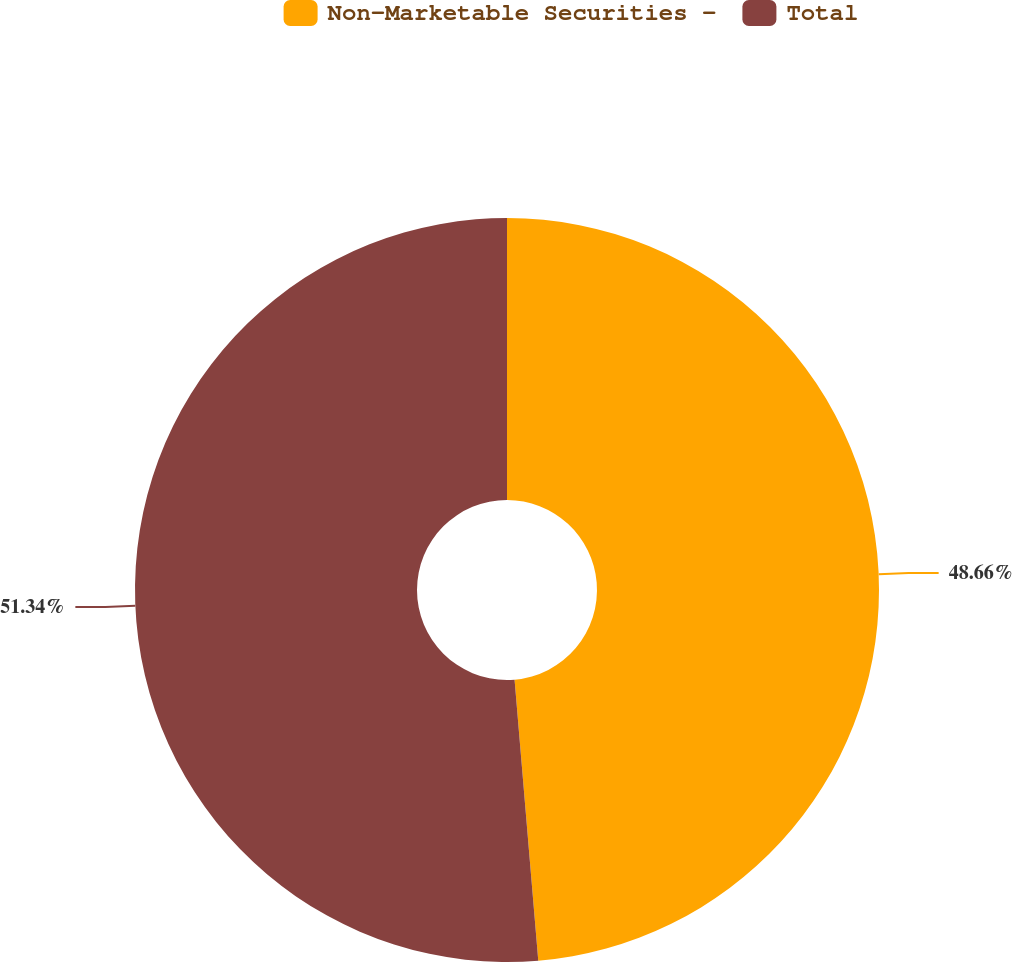<chart> <loc_0><loc_0><loc_500><loc_500><pie_chart><fcel>Non-Marketable Securities -<fcel>Total<nl><fcel>48.66%<fcel>51.34%<nl></chart> 